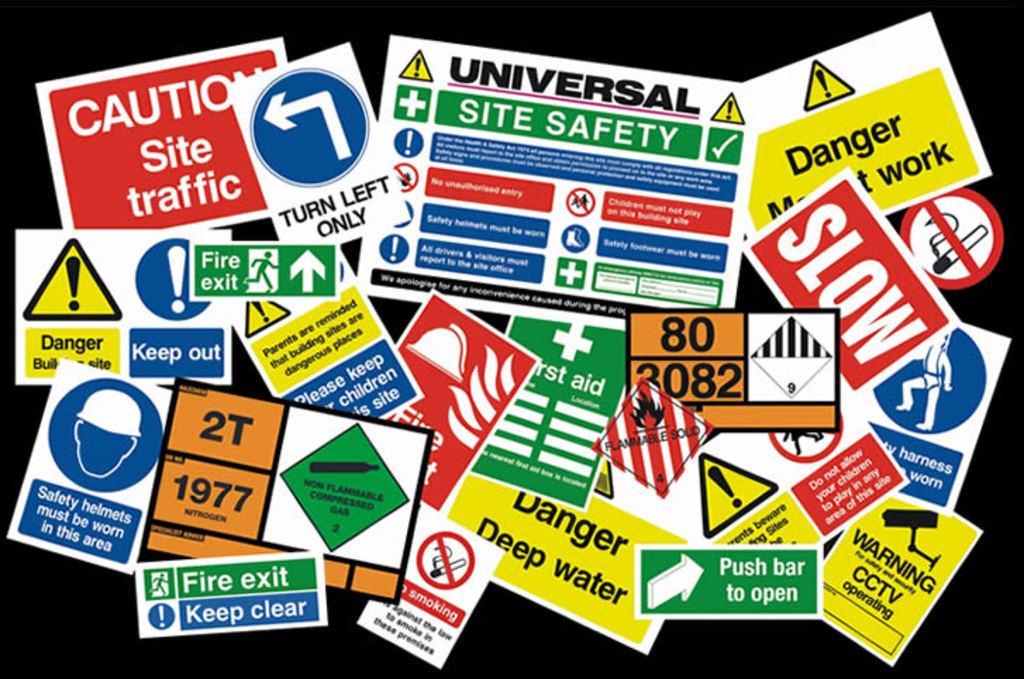How would you summarize this image in a sentence or two? In this picture we can see some posters, there is a dark background, we can see some symbols, text and numbers present on these posters. 